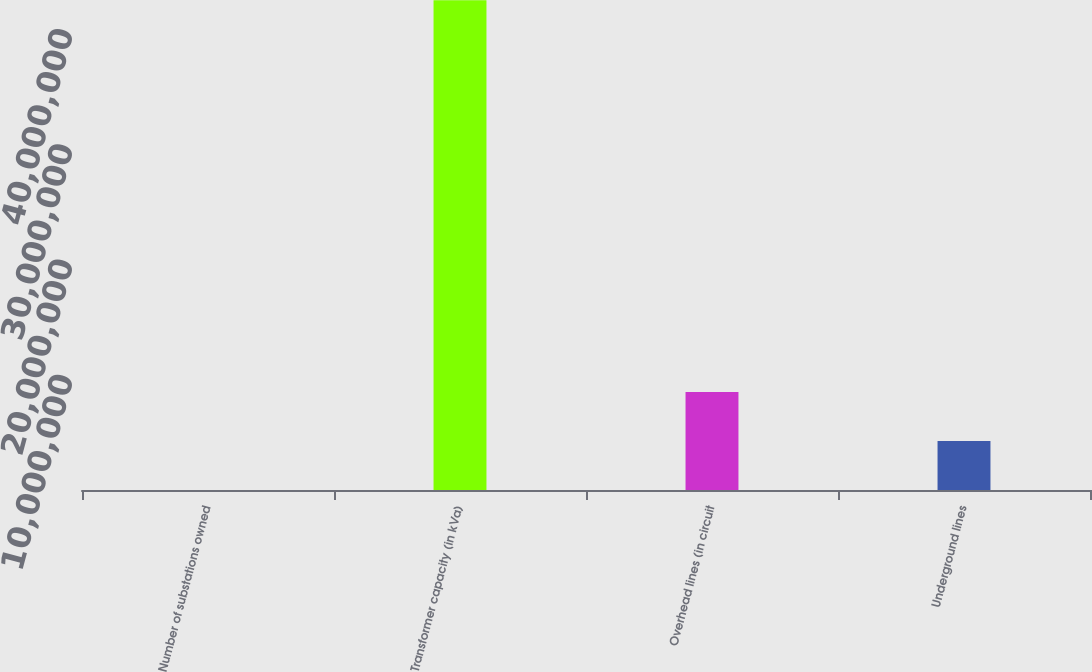Convert chart to OTSL. <chart><loc_0><loc_0><loc_500><loc_500><bar_chart><fcel>Number of substations owned<fcel>Transformer capacity (in kVa)<fcel>Overhead lines (in circuit<fcel>Underground lines<nl><fcel>510<fcel>4.2516e+07<fcel>8.50361e+06<fcel>4.25206e+06<nl></chart> 